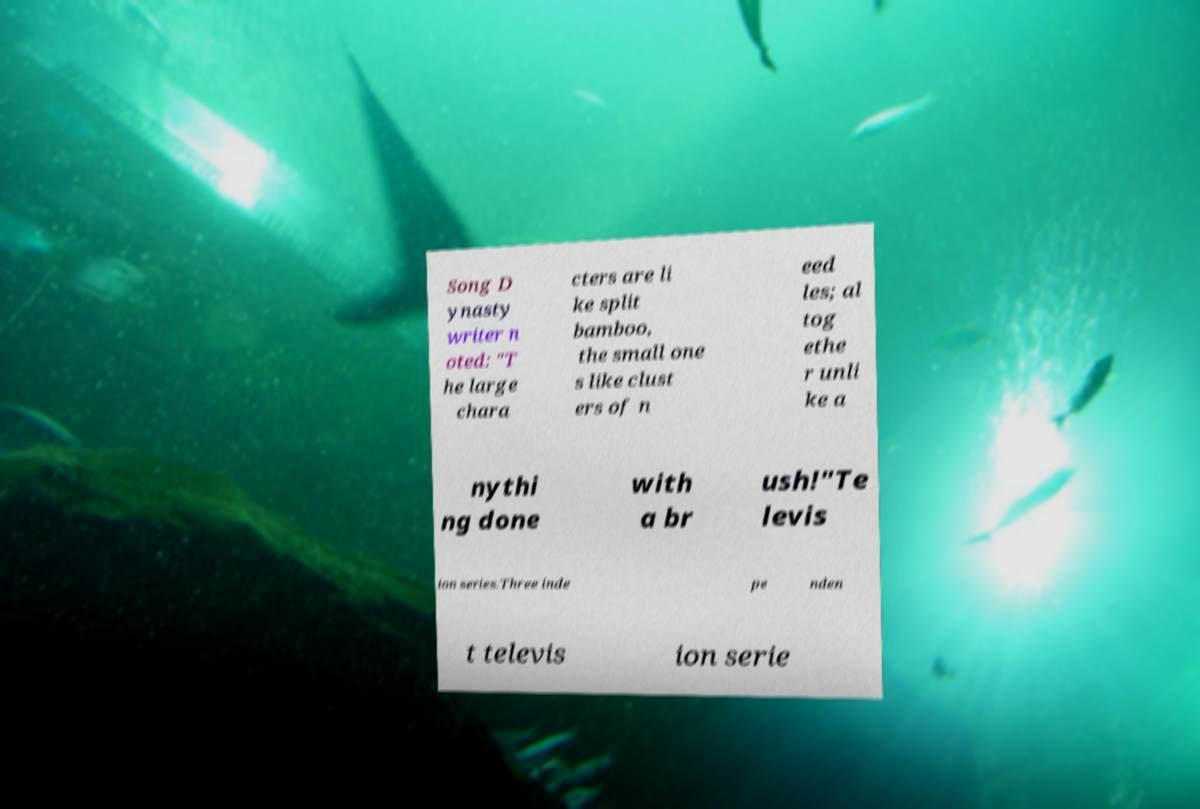For documentation purposes, I need the text within this image transcribed. Could you provide that? Song D ynasty writer n oted: "T he large chara cters are li ke split bamboo, the small one s like clust ers of n eed les; al tog ethe r unli ke a nythi ng done with a br ush!"Te levis ion series.Three inde pe nden t televis ion serie 